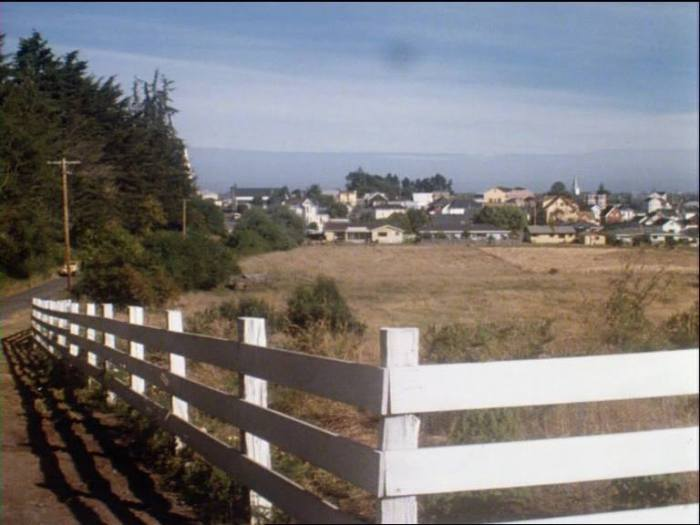Imagine you are standing at this spot looking over the town. Describe a day in the life of someone living there. Standing at this spot, you begin your day as the morning sun gently rises over the horizon, casting a golden hue over the coastal town. The day starts early here; the gentle sounds of waves lapping against the shore mix with the distant calls of seabirds. As a resident, you might head to the local bakery, greeted by the warm aroma of fresh bread and pastries. The streets slowly come to life as children make their way to school, and fishermen prepare their boats for a day's work on the bay. By mid-morning, local shops open, welcoming a mix of neighbors and the occasional tourists drawn by the town's charm. You might work at the local market, selling crafts, fresh produce, or seafood. Lunchtime sees families and friends gathering at cozy diners and cafes, where the chatter is light and the food full of local flavor. Afternoons could be spent tending to gardens, taking a leisurely stroll along the beach, or hiking the forest trails close by. As evening descends, the sky blazes with the colors of sunset, and the town winds down. Residents gather for community events, perhaps a local concert or a simple shared meal. The day ends with the calming sound of the ocean under a star-filled sky, as the town nestles into a peaceful quiet, ready to begin the cycle anew with the morning light.  Describe a quick snapshot of daily life in this town. In this picturesque coastal town, daily life is a blend of simplicity and community spirit. As dawn breaks, the town awakens to the sound of seabirds and the gentle waves of the bay. Locals greet each other on their way to the bakery, post office, or the small fishing docks. The market buzzes during the morning hours, filled with fresh produce and the day's catch. By afternoon, children play in the open fields, and adults take time for leisure or small tasks around their homes and gardens. As the sun sets, the community often gathers for shared meals or events, reinforcing the close-knit bonds that make this town a cozy and welcoming place to call home. 